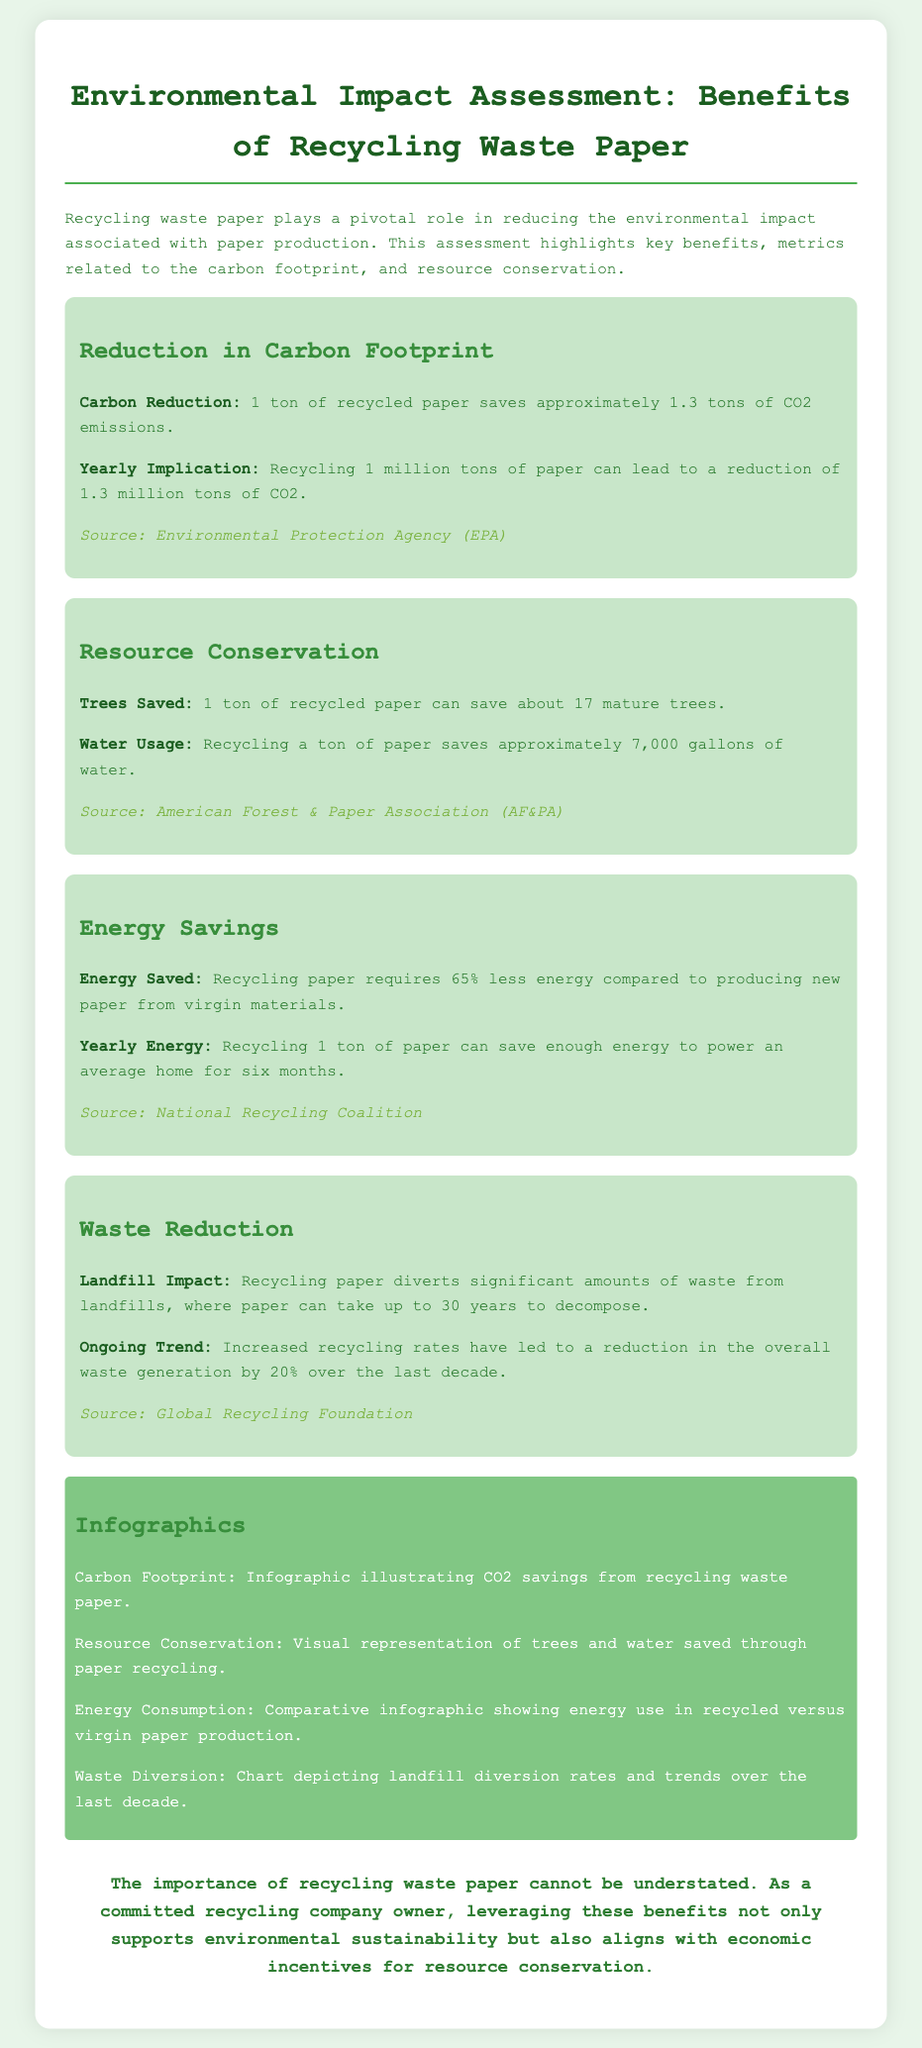what is the carbon reduction per ton of recycled paper? The document states that 1 ton of recycled paper saves approximately 1.3 tons of CO2 emissions.
Answer: 1.3 tons how many mature trees can be saved by recycling 1 ton of paper? The document mentions that 1 ton of recycled paper can save about 17 mature trees.
Answer: 17 trees what percentage less energy is required to recycle paper compared to producing new paper? The document indicates that recycling paper requires 65% less energy compared to producing new paper from virgin materials.
Answer: 65% how much water is saved by recycling 1 ton of paper? The document states that recycling a ton of paper saves approximately 7,000 gallons of water.
Answer: 7,000 gallons what is the yearly implication of recycling 1 million tons of paper? The document mentions that recycling 1 million tons of paper can lead to a reduction of 1.3 million tons of CO2.
Answer: 1.3 million tons how long can recycling 1 ton of paper power an average home? The document states that recycling 1 ton of paper can save enough energy to power an average home for six months.
Answer: six months what is the impact of recycling paper on landfill waste? The document notes that recycling paper diverts significant amounts of waste from landfills.
Answer: significant diversion what is the trend in overall waste generation over the last decade? The document highlights that increased recycling rates have led to a reduction in the overall waste generation by 20%.
Answer: 20% reduction what type of visuals are included in the infographic section? The infographic section includes visual representations of CO2 savings, trees and water saved, energy use comparison, and landfill diversion trends.
Answer: various visual representations 